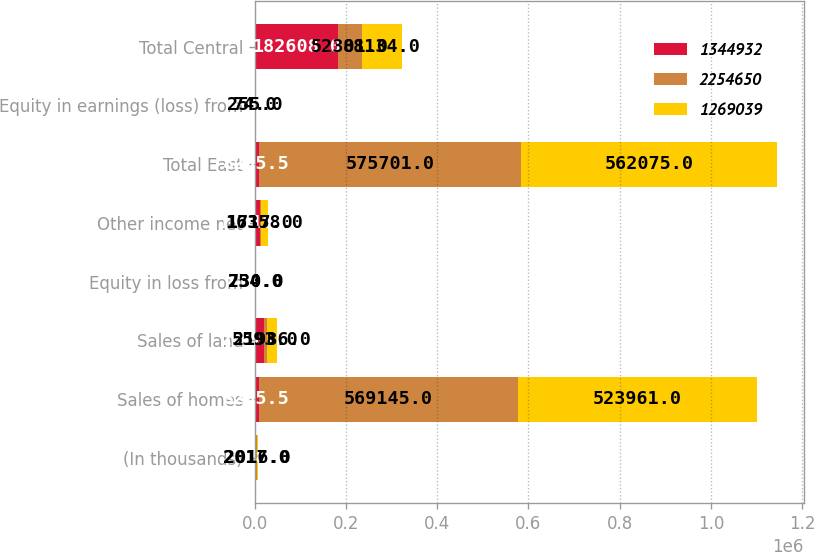Convert chart. <chart><loc_0><loc_0><loc_500><loc_500><stacked_bar_chart><ecel><fcel>(In thousands)<fcel>Sales of homes<fcel>Sales of land<fcel>Equity in loss from<fcel>Other income net<fcel>Total East<fcel>Equity in earnings (loss) from<fcel>Total Central<nl><fcel>1.34493e+06<fcel>2018<fcel>8205.5<fcel>20287<fcel>818<fcel>10818<fcel>8205.5<fcel>691<fcel>182608<nl><fcel>2.25465e+06<fcel>2017<fcel>569145<fcel>5593<fcel>754<fcel>1717<fcel>575701<fcel>255<fcel>52301<nl><fcel>1.26904e+06<fcel>2016<fcel>523961<fcel>21986<fcel>230<fcel>16358<fcel>562075<fcel>74<fcel>88134<nl></chart> 